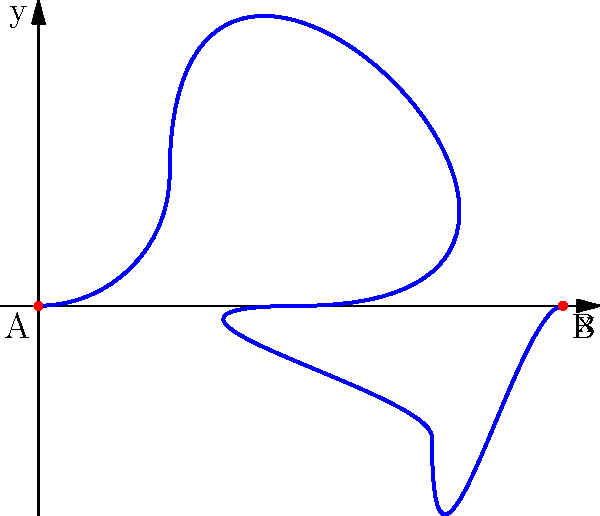You want to create a decorative display for your noodle shop using a single strand of Biang Biang noodle. The noodle needs to form a knot pattern that follows the curve given by the equation $y = \sin(\frac{\pi x}{2})$ from $x = 0$ to $x = 4$. What is the minimum length of noodle required to create this pattern, rounded to the nearest centimeter? To find the minimum length of the noodle, we need to calculate the arc length of the given curve. Here's how we can do it step-by-step:

1) The arc length formula for a curve $y = f(x)$ from $a$ to $b$ is:

   $$L = \int_{a}^{b} \sqrt{1 + [f'(x)]^2} dx$$

2) In our case, $f(x) = \sin(\frac{\pi x}{2})$, $a = 0$, and $b = 4$.

3) First, let's find $f'(x)$:
   
   $$f'(x) = \frac{\pi}{2} \cos(\frac{\pi x}{2})$$

4) Now, let's substitute this into our arc length formula:

   $$L = \int_{0}^{4} \sqrt{1 + [\frac{\pi}{2} \cos(\frac{\pi x}{2})]^2} dx$$

5) This integral is difficult to solve analytically, so we'll use numerical integration. Using a computer algebra system or numerical integration tool, we get:

   $$L \approx 5.52 \text{ cm}$$

6) Rounding to the nearest centimeter:

   $$L \approx 6 \text{ cm}$$

Therefore, the minimum length of noodle required is approximately 6 cm.
Answer: 6 cm 